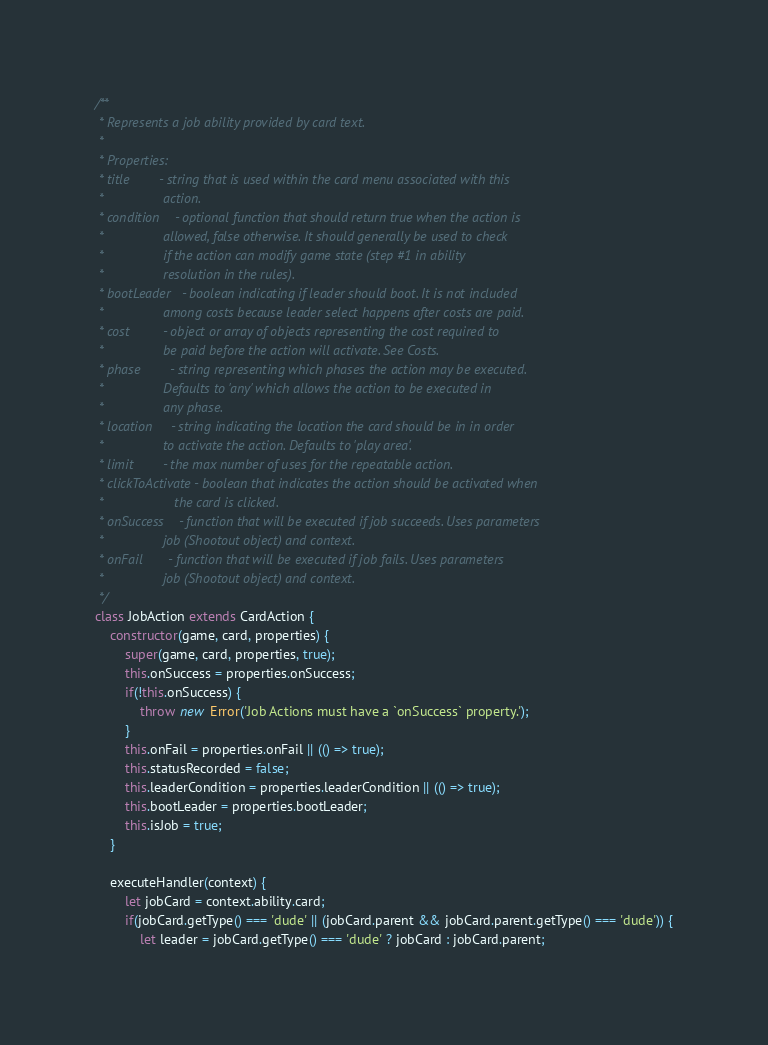Convert code to text. <code><loc_0><loc_0><loc_500><loc_500><_JavaScript_>/**
 * Represents a job ability provided by card text.
 *
 * Properties:
 * title        - string that is used within the card menu associated with this
 *                action.
 * condition    - optional function that should return true when the action is
 *                allowed, false otherwise. It should generally be used to check
 *                if the action can modify game state (step #1 in ability
 *                resolution in the rules).
 * bootLeader   - boolean indicating if leader should boot. It is not included
 *                among costs because leader select happens after costs are paid.
 * cost         - object or array of objects representing the cost required to
 *                be paid before the action will activate. See Costs.
 * phase        - string representing which phases the action may be executed.
 *                Defaults to 'any' which allows the action to be executed in
 *                any phase.
 * location     - string indicating the location the card should be in in order
 *                to activate the action. Defaults to 'play area'.
 * limit        - the max number of uses for the repeatable action.
 * clickToActivate - boolean that indicates the action should be activated when
 *                   the card is clicked.
 * onSuccess    - function that will be executed if job succeeds. Uses parameters
 *                job (Shootout object) and context.
 * onFail       - function that will be executed if job fails. Uses parameters
 *                job (Shootout object) and context.
 */
class JobAction extends CardAction {
    constructor(game, card, properties) {
        super(game, card, properties, true);
        this.onSuccess = properties.onSuccess;
        if(!this.onSuccess) {
            throw new Error('Job Actions must have a `onSuccess` property.');
        }
        this.onFail = properties.onFail || (() => true);
        this.statusRecorded = false;
        this.leaderCondition = properties.leaderCondition || (() => true);
        this.bootLeader = properties.bootLeader;
        this.isJob = true;
    }

    executeHandler(context) {
        let jobCard = context.ability.card;
        if(jobCard.getType() === 'dude' || (jobCard.parent && jobCard.parent.getType() === 'dude')) {
            let leader = jobCard.getType() === 'dude' ? jobCard : jobCard.parent;</code> 